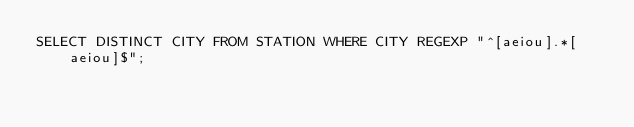Convert code to text. <code><loc_0><loc_0><loc_500><loc_500><_SQL_>SELECT DISTINCT CITY FROM STATION WHERE CITY REGEXP "^[aeiou].*[aeiou]$";
</code> 